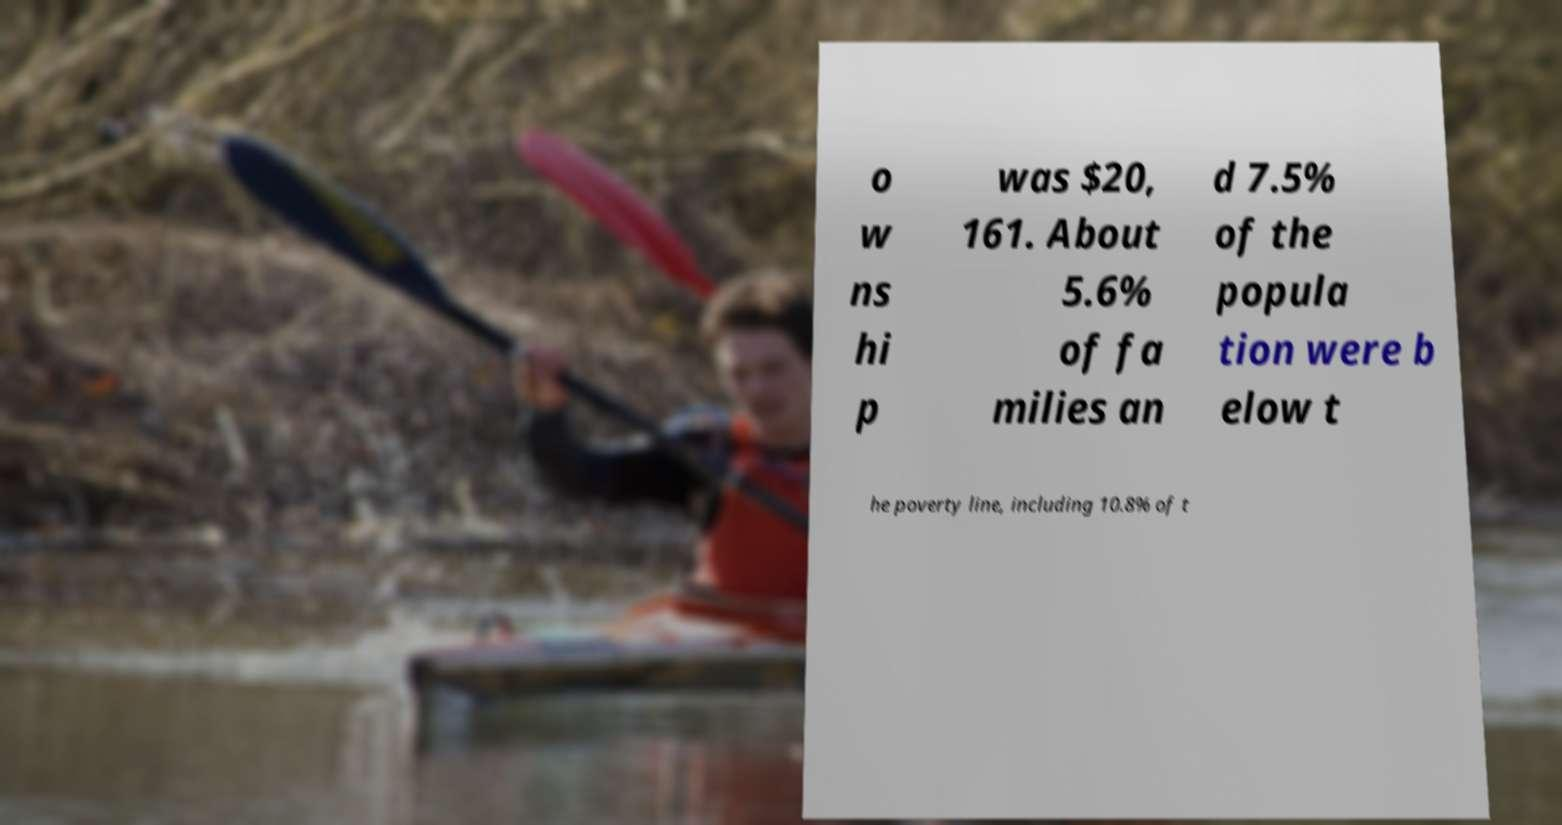Please identify and transcribe the text found in this image. o w ns hi p was $20, 161. About 5.6% of fa milies an d 7.5% of the popula tion were b elow t he poverty line, including 10.8% of t 